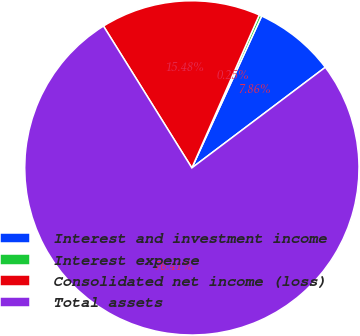Convert chart to OTSL. <chart><loc_0><loc_0><loc_500><loc_500><pie_chart><fcel>Interest and investment income<fcel>Interest expense<fcel>Consolidated net income (loss)<fcel>Total assets<nl><fcel>7.86%<fcel>0.25%<fcel>15.48%<fcel>76.41%<nl></chart> 